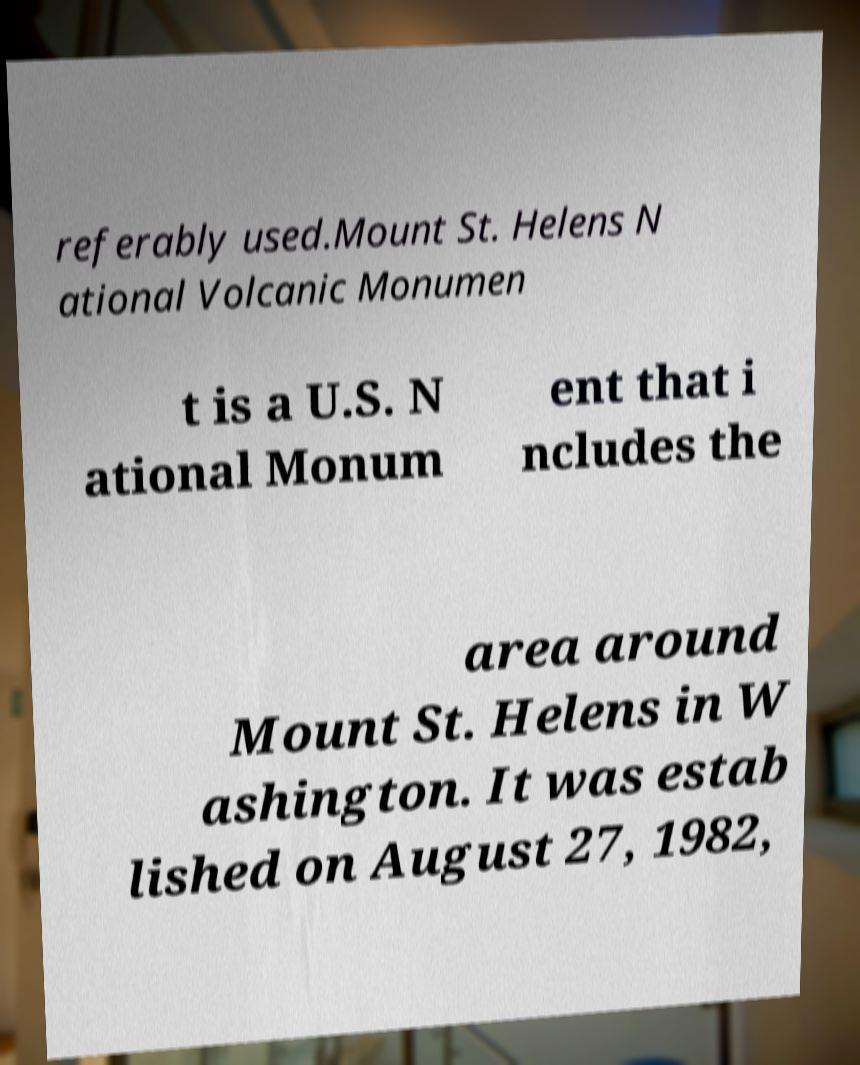What messages or text are displayed in this image? I need them in a readable, typed format. referably used.Mount St. Helens N ational Volcanic Monumen t is a U.S. N ational Monum ent that i ncludes the area around Mount St. Helens in W ashington. It was estab lished on August 27, 1982, 